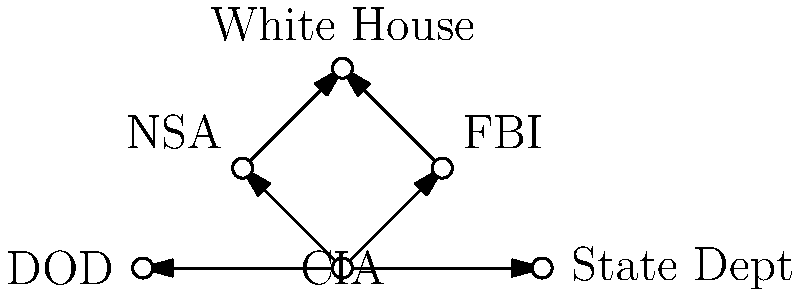Based on the network diagram showing connections between government agencies and classified information flow, which agency appears to be the central hub for information distribution? To determine the central hub for information distribution, we need to analyze the connections between the agencies in the network diagram. Let's break it down step-by-step:

1. Identify all agencies in the diagram:
   - CIA
   - FBI
   - NSA
   - White House
   - DOD (Department of Defense)
   - State Department

2. Count the number of connections for each agency:
   - CIA: 5 connections (to FBI, NSA, DOD, State Dept, and indirectly to White House)
   - FBI: 2 connections (to CIA and White House)
   - NSA: 2 connections (to CIA and White House)
   - White House: 2 connections (from FBI and NSA)
   - DOD: 1 connection (to CIA)
   - State Department: 1 connection (to CIA)

3. Analyze the direction of information flow:
   - All arrows originate from the CIA, indicating that it's the source of information for other agencies.
   - The CIA has direct connections to all agencies except the White House.
   - The White House receives information indirectly through the FBI and NSA.

4. Consider the position in the diagram:
   - The CIA is positioned at the center of the network, with all other agencies branching out from it.

Based on this analysis, the CIA has the most connections, is the source of information for all other agencies, and is centrally positioned in the network. Therefore, the CIA appears to be the central hub for information distribution in this network of government agencies and classified information flow.
Answer: CIA 